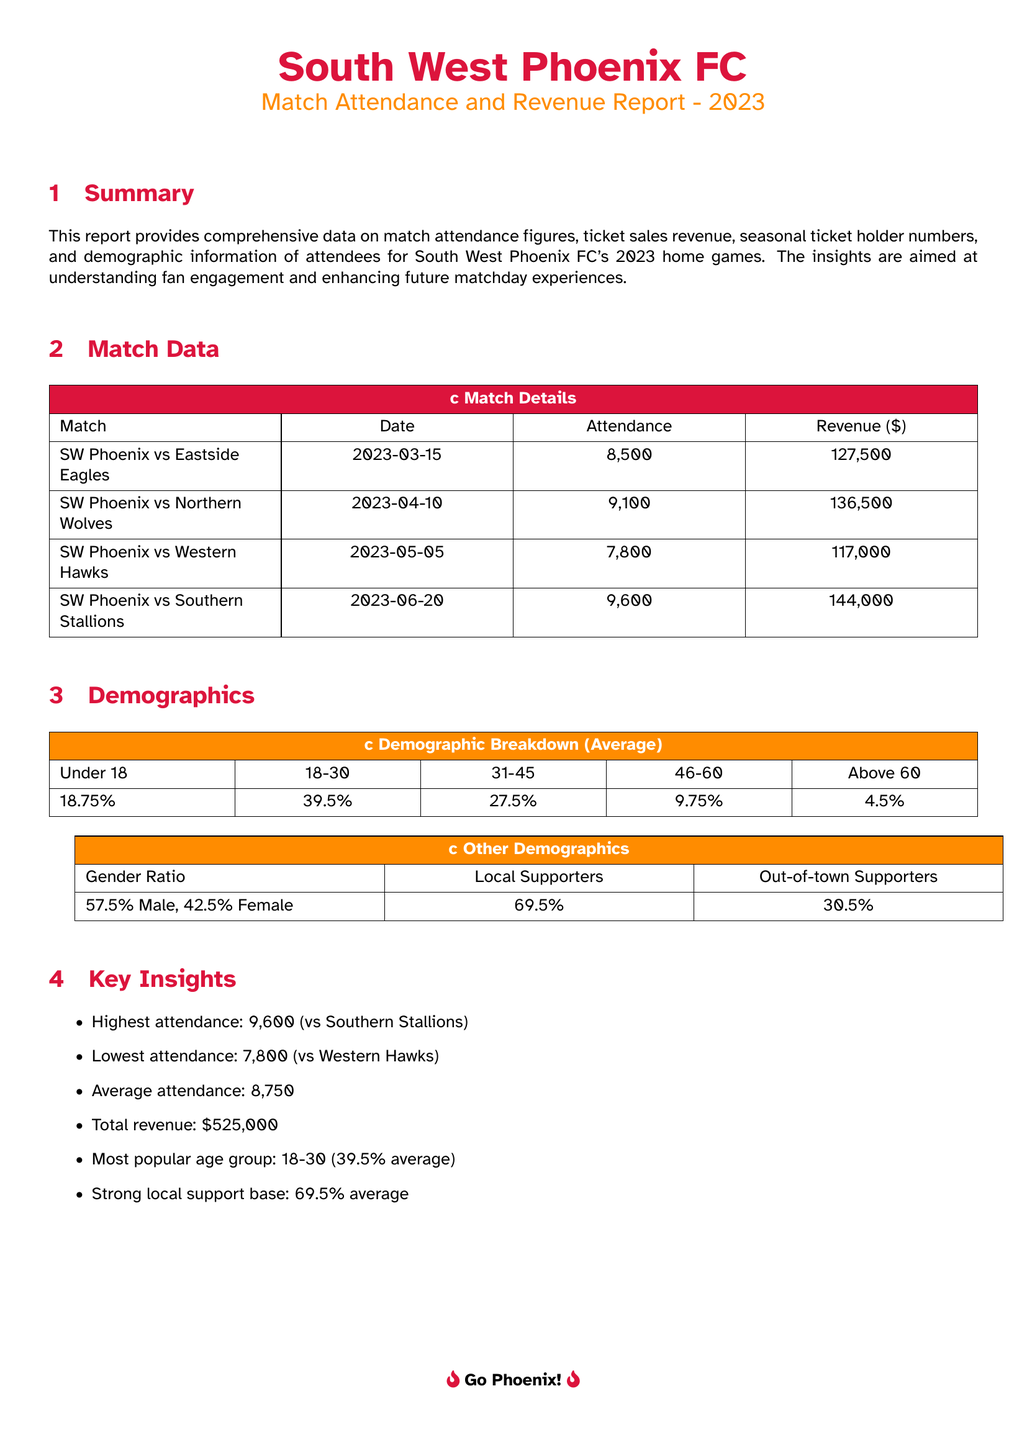What was the attendance for the match against Eastside Eagles? The attendance for the match against Eastside Eagles is listed in the Match Data section.
Answer: 8,500 What is the revenue generated from the match against Northern Wolves? The revenue generated from the match against Northern Wolves can be found in the Match Data section.
Answer: 136,500 Which age group represents the highest percentage of attendees? The demographic breakdown indicates the age group with the highest percentage of attendees in the Average category.
Answer: 18-30 What percentage of attendees were local supporters? The document includes demographic information stating the percentage of local supporters.
Answer: 69.5% When did the match against Southern Stallions take place? The date of the match against Southern Stallions is provided in the Match Data section.
Answer: 2023-06-20 What is the average attendance across the listed home games? The average attendance is calculated based on the provided attendance figures in the Match Data section.
Answer: 8,750 Which game had the highest attendance? The Match Data section highlights which game had the highest attendance figure.
Answer: versus Southern Stallions What is the gender ratio of attendees? The gender ratio is outlined in the Other Demographics section, providing a breakdown of male and female attendees.
Answer: 57.5% Male, 42.5% Female What was the total revenue for the home games in 2023? The total revenue is the sum of revenue from each match, indicated in the Match Data section.
Answer: 525,000 